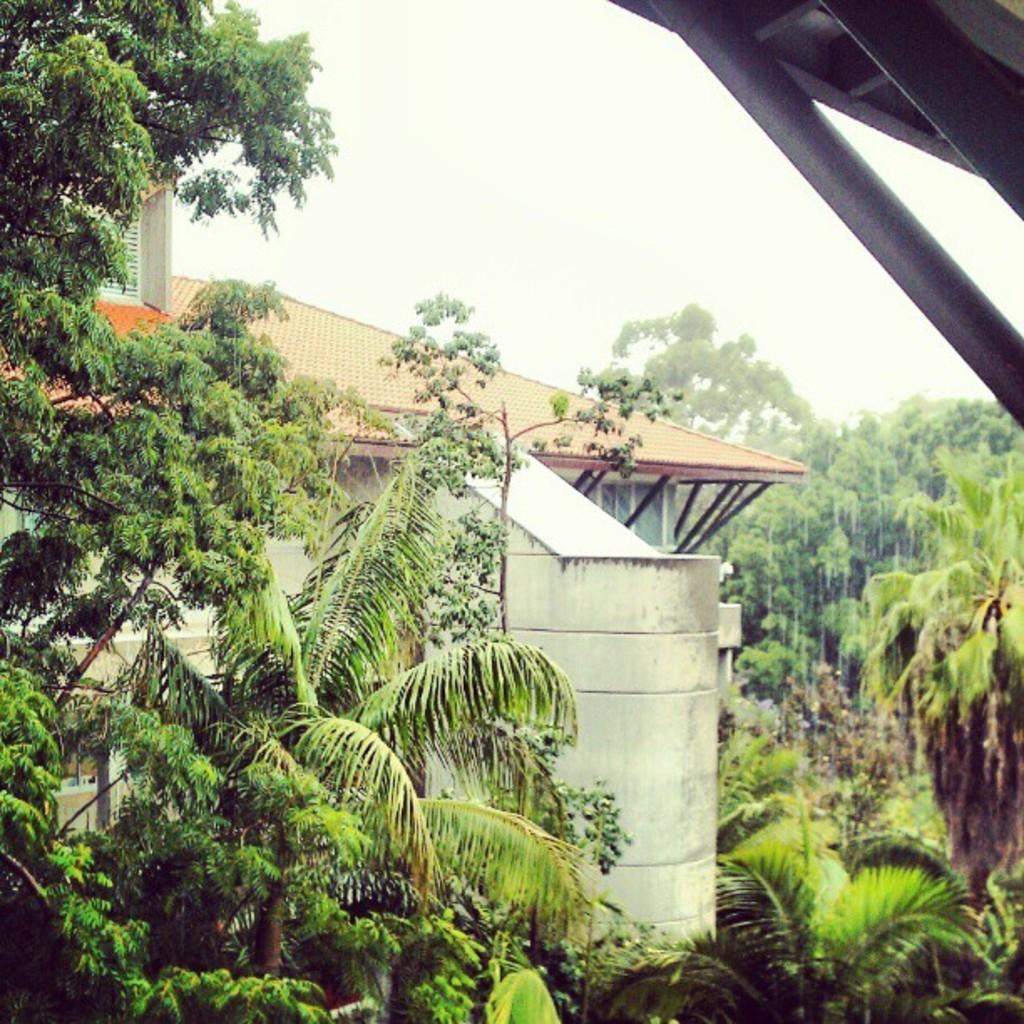What type of vegetation can be seen in the image? There are trees, plants, and grass in the image. What type of structure is present in the image? There is a building in the image. What part of the natural environment is visible in the image? The sky is visible in the image. What type of insect can be seen flying in the image? There are no insects visible in the image. 